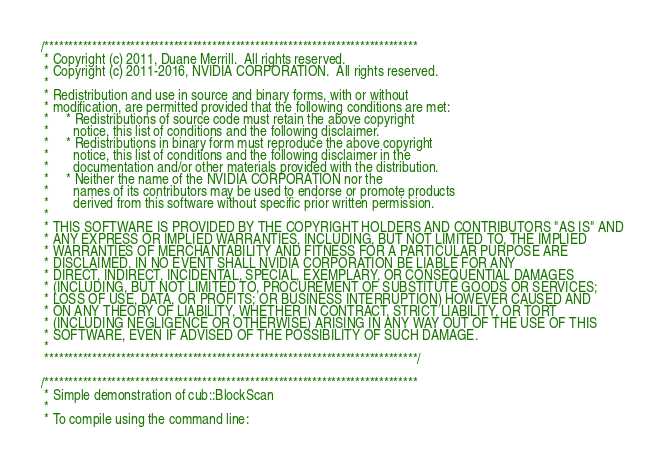<code> <loc_0><loc_0><loc_500><loc_500><_Cuda_>/******************************************************************************
 * Copyright (c) 2011, Duane Merrill.  All rights reserved.
 * Copyright (c) 2011-2016, NVIDIA CORPORATION.  All rights reserved.
 *
 * Redistribution and use in source and binary forms, with or without
 * modification, are permitted provided that the following conditions are met:
 *     * Redistributions of source code must retain the above copyright
 *       notice, this list of conditions and the following disclaimer.
 *     * Redistributions in binary form must reproduce the above copyright
 *       notice, this list of conditions and the following disclaimer in the
 *       documentation and/or other materials provided with the distribution.
 *     * Neither the name of the NVIDIA CORPORATION nor the
 *       names of its contributors may be used to endorse or promote products
 *       derived from this software without specific prior written permission.
 *
 * THIS SOFTWARE IS PROVIDED BY THE COPYRIGHT HOLDERS AND CONTRIBUTORS "AS IS" AND
 * ANY EXPRESS OR IMPLIED WARRANTIES, INCLUDING, BUT NOT LIMITED TO, THE IMPLIED
 * WARRANTIES OF MERCHANTABILITY AND FITNESS FOR A PARTICULAR PURPOSE ARE
 * DISCLAIMED. IN NO EVENT SHALL NVIDIA CORPORATION BE LIABLE FOR ANY
 * DIRECT, INDIRECT, INCIDENTAL, SPECIAL, EXEMPLARY, OR CONSEQUENTIAL DAMAGES
 * (INCLUDING, BUT NOT LIMITED TO, PROCUREMENT OF SUBSTITUTE GOODS OR SERVICES;
 * LOSS OF USE, DATA, OR PROFITS; OR BUSINESS INTERRUPTION) HOWEVER CAUSED AND
 * ON ANY THEORY OF LIABILITY, WHETHER IN CONTRACT, STRICT LIABILITY, OR TORT
 * (INCLUDING NEGLIGENCE OR OTHERWISE) ARISING IN ANY WAY OUT OF THE USE OF THIS
 * SOFTWARE, EVEN IF ADVISED OF THE POSSIBILITY OF SUCH DAMAGE.
 *
 ******************************************************************************/

/******************************************************************************
 * Simple demonstration of cub::BlockScan
 *
 * To compile using the command line:</code> 